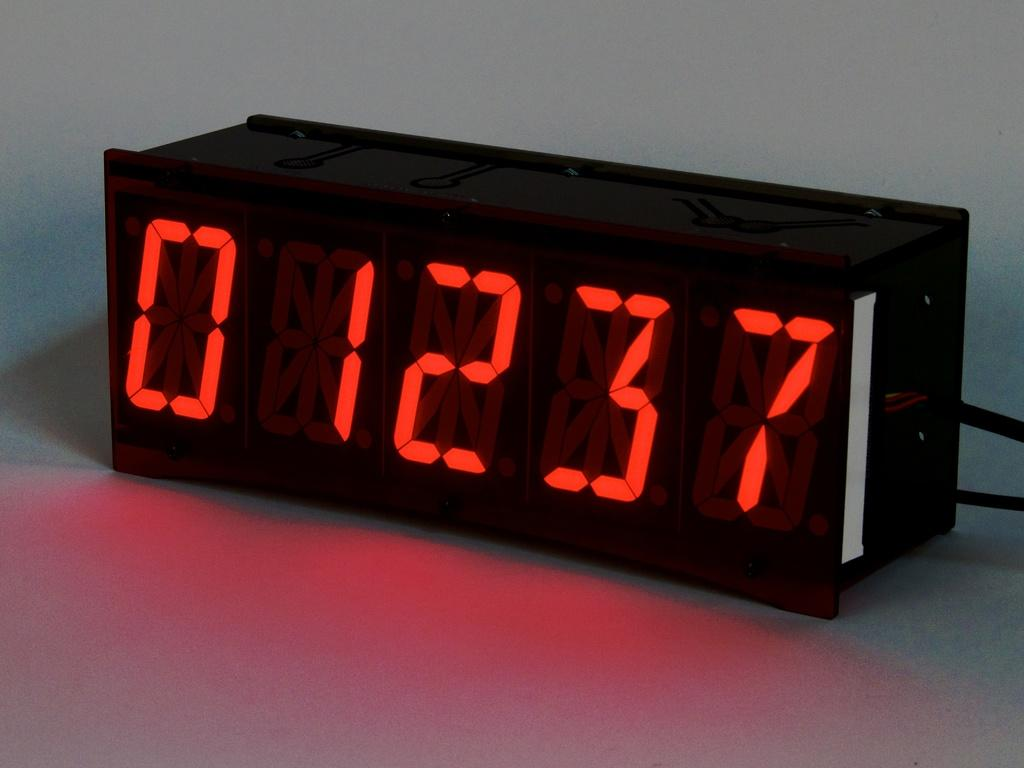<image>
Create a compact narrative representing the image presented. a black digital clock with red letters displaying 01237 